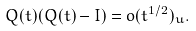Convert formula to latex. <formula><loc_0><loc_0><loc_500><loc_500>& Q ( t ) ( Q ( t ) - I ) = o ( t ^ { 1 / 2 } ) _ { u } .</formula> 